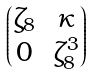<formula> <loc_0><loc_0><loc_500><loc_500>\begin{pmatrix} \zeta _ { 8 } & \kappa \\ 0 & \zeta _ { 8 } ^ { 3 } \end{pmatrix}</formula> 